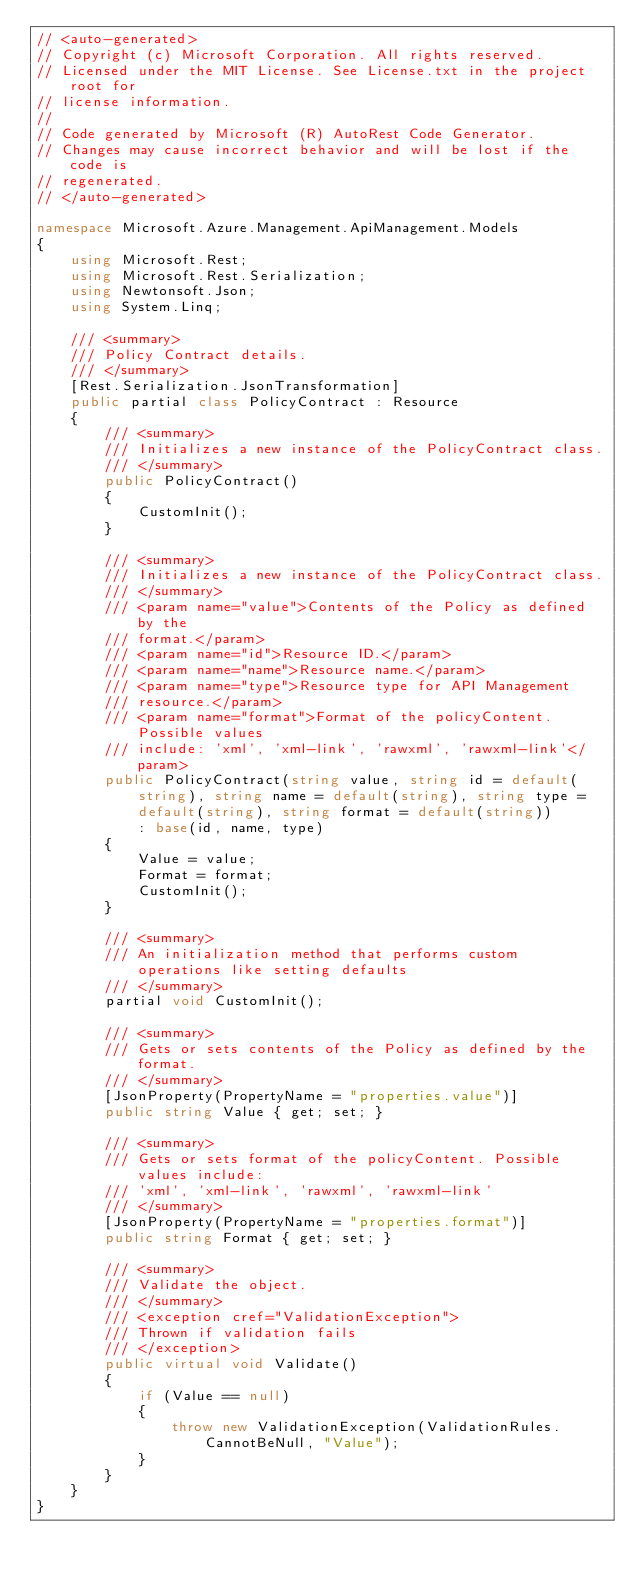<code> <loc_0><loc_0><loc_500><loc_500><_C#_>// <auto-generated>
// Copyright (c) Microsoft Corporation. All rights reserved.
// Licensed under the MIT License. See License.txt in the project root for
// license information.
//
// Code generated by Microsoft (R) AutoRest Code Generator.
// Changes may cause incorrect behavior and will be lost if the code is
// regenerated.
// </auto-generated>

namespace Microsoft.Azure.Management.ApiManagement.Models
{
    using Microsoft.Rest;
    using Microsoft.Rest.Serialization;
    using Newtonsoft.Json;
    using System.Linq;

    /// <summary>
    /// Policy Contract details.
    /// </summary>
    [Rest.Serialization.JsonTransformation]
    public partial class PolicyContract : Resource
    {
        /// <summary>
        /// Initializes a new instance of the PolicyContract class.
        /// </summary>
        public PolicyContract()
        {
            CustomInit();
        }

        /// <summary>
        /// Initializes a new instance of the PolicyContract class.
        /// </summary>
        /// <param name="value">Contents of the Policy as defined by the
        /// format.</param>
        /// <param name="id">Resource ID.</param>
        /// <param name="name">Resource name.</param>
        /// <param name="type">Resource type for API Management
        /// resource.</param>
        /// <param name="format">Format of the policyContent. Possible values
        /// include: 'xml', 'xml-link', 'rawxml', 'rawxml-link'</param>
        public PolicyContract(string value, string id = default(string), string name = default(string), string type = default(string), string format = default(string))
            : base(id, name, type)
        {
            Value = value;
            Format = format;
            CustomInit();
        }

        /// <summary>
        /// An initialization method that performs custom operations like setting defaults
        /// </summary>
        partial void CustomInit();

        /// <summary>
        /// Gets or sets contents of the Policy as defined by the format.
        /// </summary>
        [JsonProperty(PropertyName = "properties.value")]
        public string Value { get; set; }

        /// <summary>
        /// Gets or sets format of the policyContent. Possible values include:
        /// 'xml', 'xml-link', 'rawxml', 'rawxml-link'
        /// </summary>
        [JsonProperty(PropertyName = "properties.format")]
        public string Format { get; set; }

        /// <summary>
        /// Validate the object.
        /// </summary>
        /// <exception cref="ValidationException">
        /// Thrown if validation fails
        /// </exception>
        public virtual void Validate()
        {
            if (Value == null)
            {
                throw new ValidationException(ValidationRules.CannotBeNull, "Value");
            }
        }
    }
}
</code> 